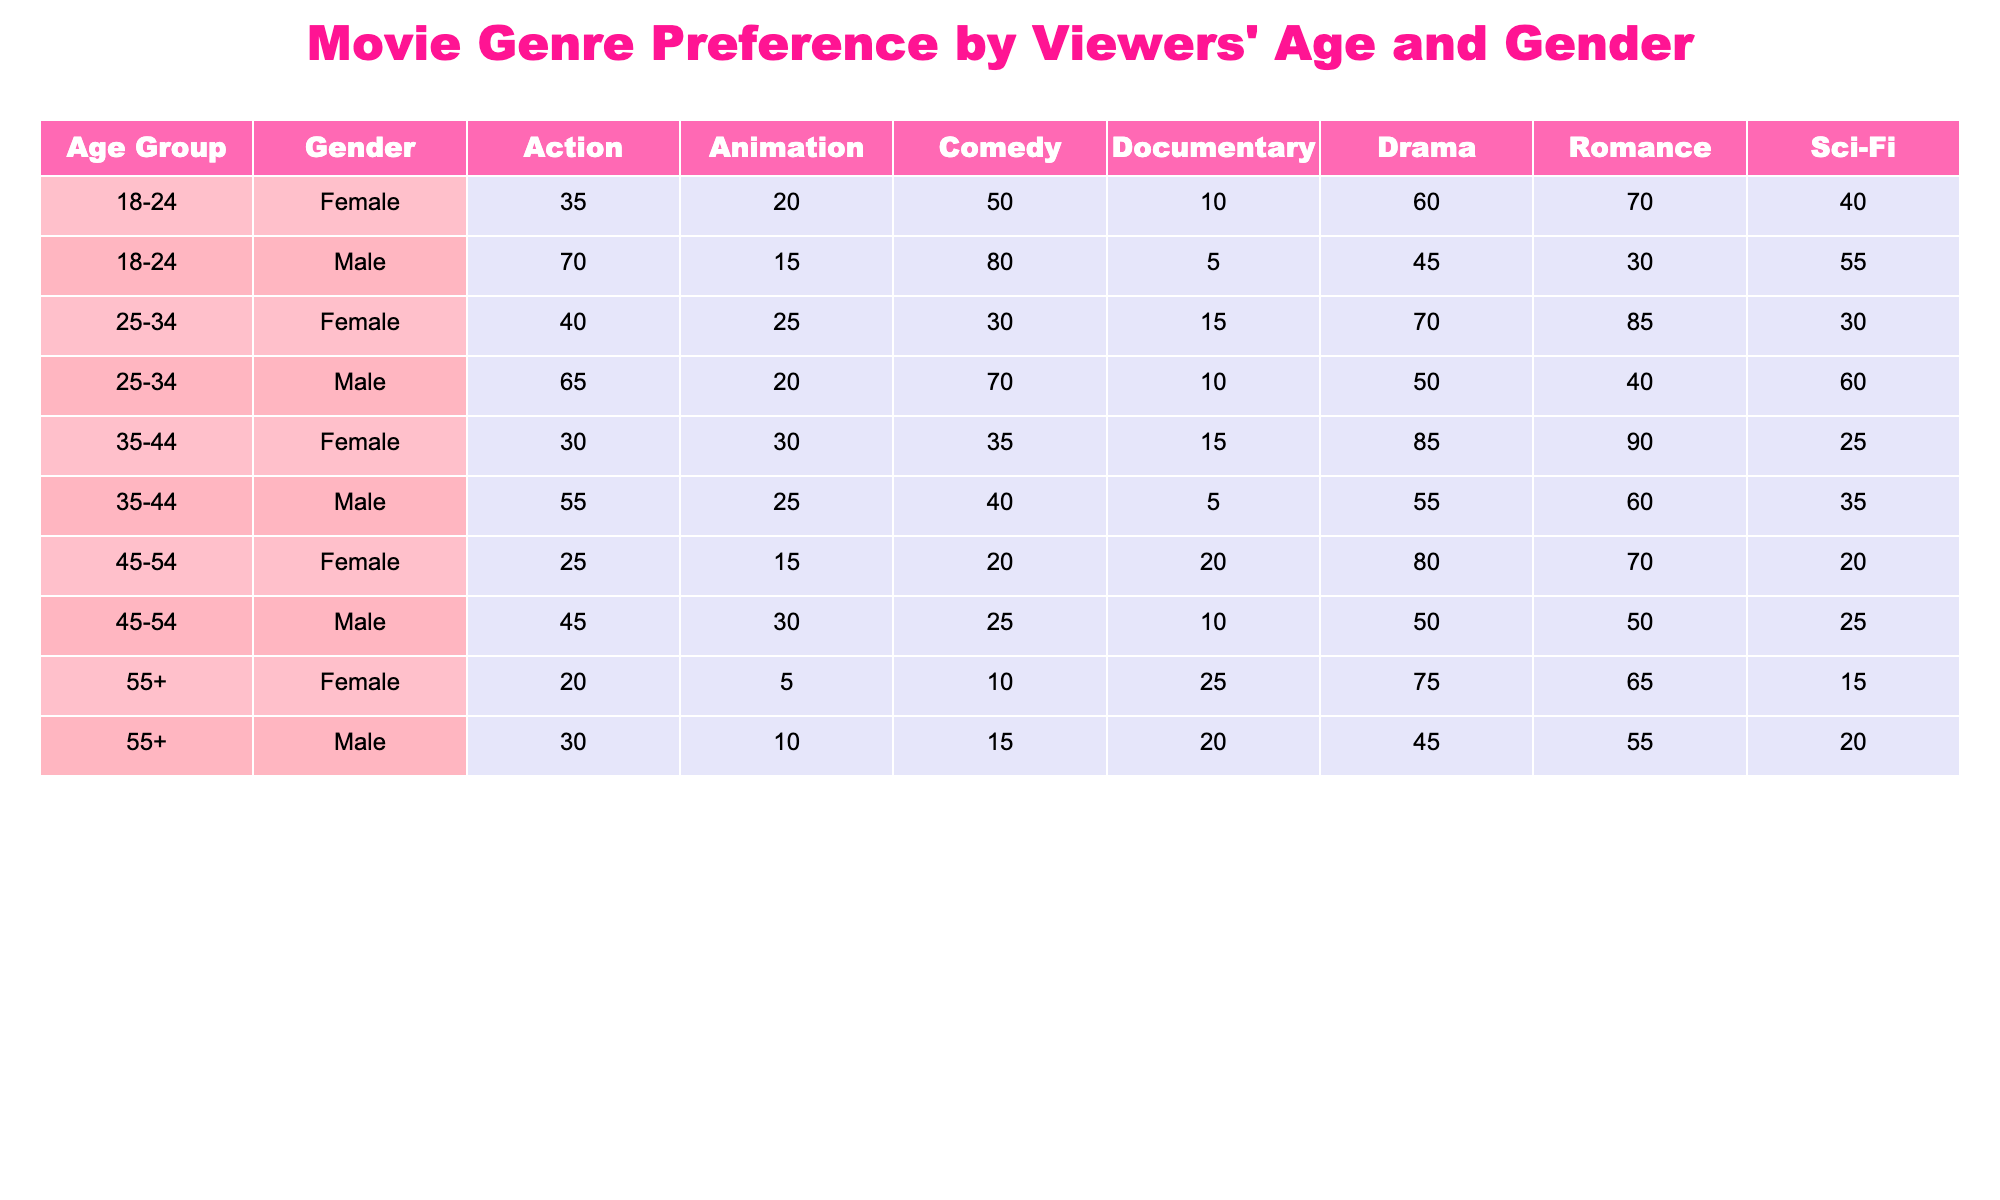What genre do female viewers in the 18-24 age group prefer the most? According to the table, female viewers aged 18-24 prefer Romance with a score of 70, which is higher than any other genre listed for this age group.
Answer: Romance Which gender has a higher preference for Action movies in the 25-34 age group? The table shows that male viewers in the 25-34 age group have a preference score of 65 for Action, while female viewers have a score of 40. Thus, males have a higher preference for Action movies in this age group.
Answer: Male What is the total preference score for Drama across all age groups for female viewers? To find the total preference score for Drama among female viewers, sum the scores in the Drama column: 60 (18-24) + 70 (25-34) + 85 (35-44) + 80 (45-54) + 75 (55+) = 370.
Answer: 370 Is it true that male viewers aged 55 and older have a higher preference for Comedy than their female counterparts? The table indicates that males aged 55+ have a score of 15 for Comedy, whereas females have a score of 10. Therefore, it is true that males have a higher preference for Comedy in this age group.
Answer: Yes What is the average preference score for Sci-Fi movies among female viewers? The Sci-Fi scores for female viewers are: 40 (18-24) + 30 (25-34) + 25 (35-44) + 20 (45-54) + 15 (55+) = 130. There are 5 data points, so the average is 130/5 = 26.
Answer: 26 Which age group shows the least preference for Animation movies among male viewers? By reviewing the Animation score for male viewers, it is seen that the 18-24 age group has a score of 15, which is lower compared to other age groups (20, 20, 30). Thus, the 18-24 age group shows the least preference.
Answer: 18-24 How much more do female viewers aged 35-44 prefer Romance movies compared to female viewers aged 45-54? The 35-44 age group scores 90 for Romance, while the 45-54 age group scores 70. The difference is 90 - 70 = 20.
Answer: 20 What is the total preference score for all genres combined for male viewers aged 45-54? The scores for male viewers aged 45-54 are: Action 45 + Comedy 25 + Drama 50 + Romance 50 + Sci-Fi 25 + Animation 30 + Documentary 10 = 235.
Answer: 235 